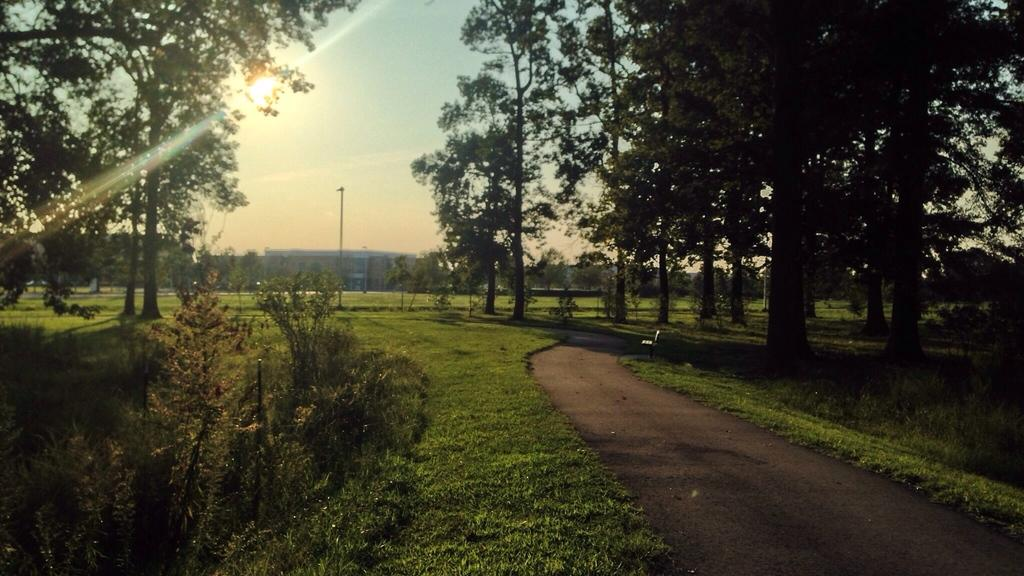Where was the image taken? The image was taken on a road. What can be seen in the background of the image? There are trees and plants in the image. What is the main feature at the bottom of the image? The bottom of the image features a road. What is visible at the top of the image? The sky is visible at the top of the image. How many cows can be seen grazing on the side of the road in the image? There are no cows visible in the image; it only features trees, plants, and the road. What type of bat is flying in the sky in the image? There are no bats visible in the sky in the image; only the sky is present. 